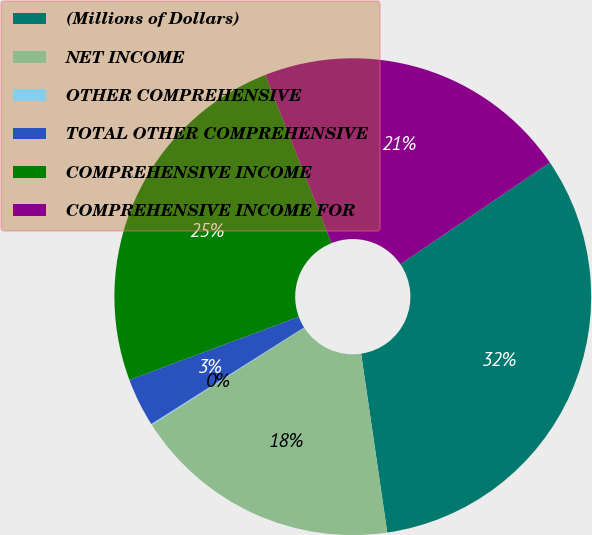Convert chart to OTSL. <chart><loc_0><loc_0><loc_500><loc_500><pie_chart><fcel>(Millions of Dollars)<fcel>NET INCOME<fcel>OTHER COMPREHENSIVE<fcel>TOTAL OTHER COMPREHENSIVE<fcel>COMPREHENSIVE INCOME<fcel>COMPREHENSIVE INCOME FOR<nl><fcel>32.2%<fcel>18.26%<fcel>0.08%<fcel>3.29%<fcel>24.69%<fcel>21.47%<nl></chart> 